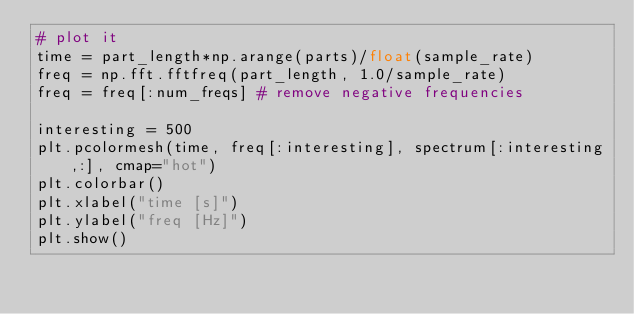Convert code to text. <code><loc_0><loc_0><loc_500><loc_500><_Python_># plot it
time = part_length*np.arange(parts)/float(sample_rate)
freq = np.fft.fftfreq(part_length, 1.0/sample_rate)
freq = freq[:num_freqs] # remove negative frequencies

interesting = 500
plt.pcolormesh(time, freq[:interesting], spectrum[:interesting,:], cmap="hot")
plt.colorbar()
plt.xlabel("time [s]")
plt.ylabel("freq [Hz]")
plt.show()
</code> 